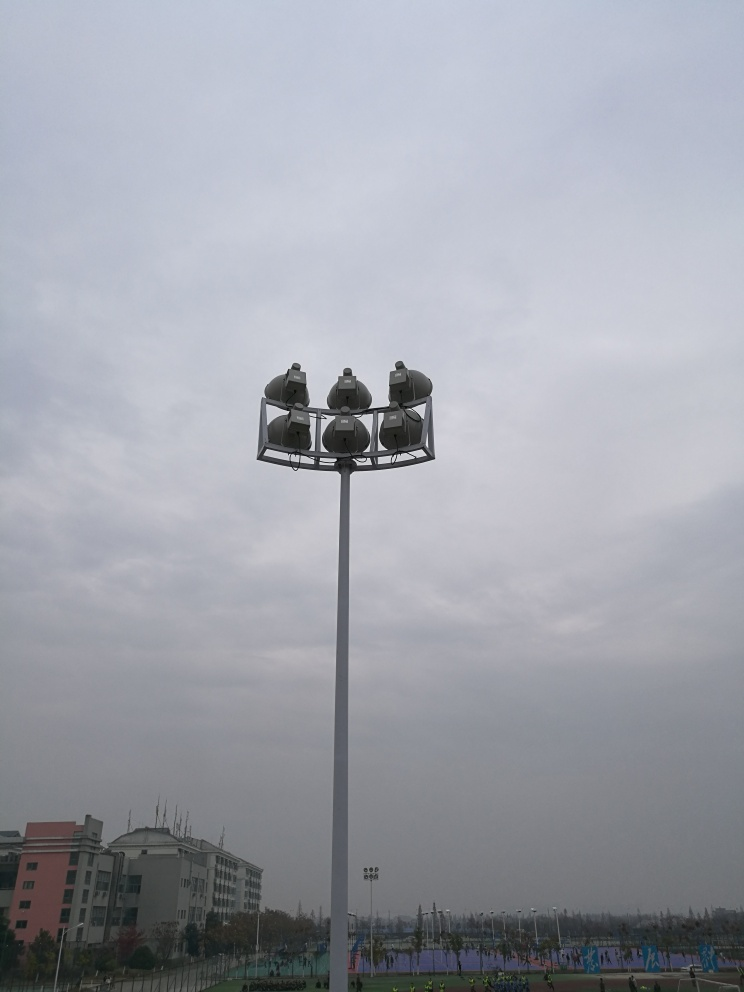What is the function of the structure shown in the image? The structure is a high-mast lighting pole equipped with multiple lighting fixtures, commonly used to illuminate expansive outdoor areas like the sports fields visible in the image. Is there a particular time of day when this lighting would be most useful? High-mast lighting is most effective and necessary during evening or nighttime hours when natural light is not sufficient to ensure safety and visibility for activities on the ground. 